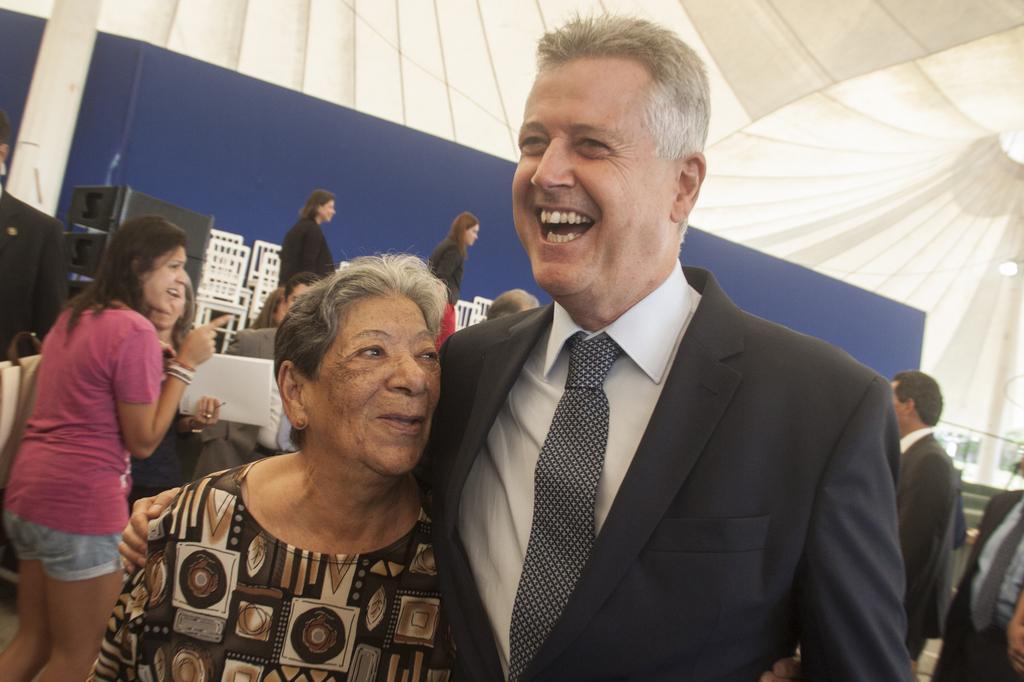Please provide a concise description of this image. In this image we can see people, chairs, devices, tent, poles and things. 